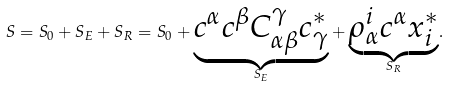Convert formula to latex. <formula><loc_0><loc_0><loc_500><loc_500>S = S _ { 0 } + S _ { E } + S _ { R } = S _ { 0 } + \underset { S _ { E } } { \underbrace { c ^ { \alpha } c ^ { \beta } C _ { \alpha \beta } ^ { \gamma } c ^ { * } _ { \gamma } } } + \underset { S _ { R } } { \underbrace { \rho _ { \alpha } ^ { i } c ^ { \alpha } x _ { i } ^ { * } } } .</formula> 